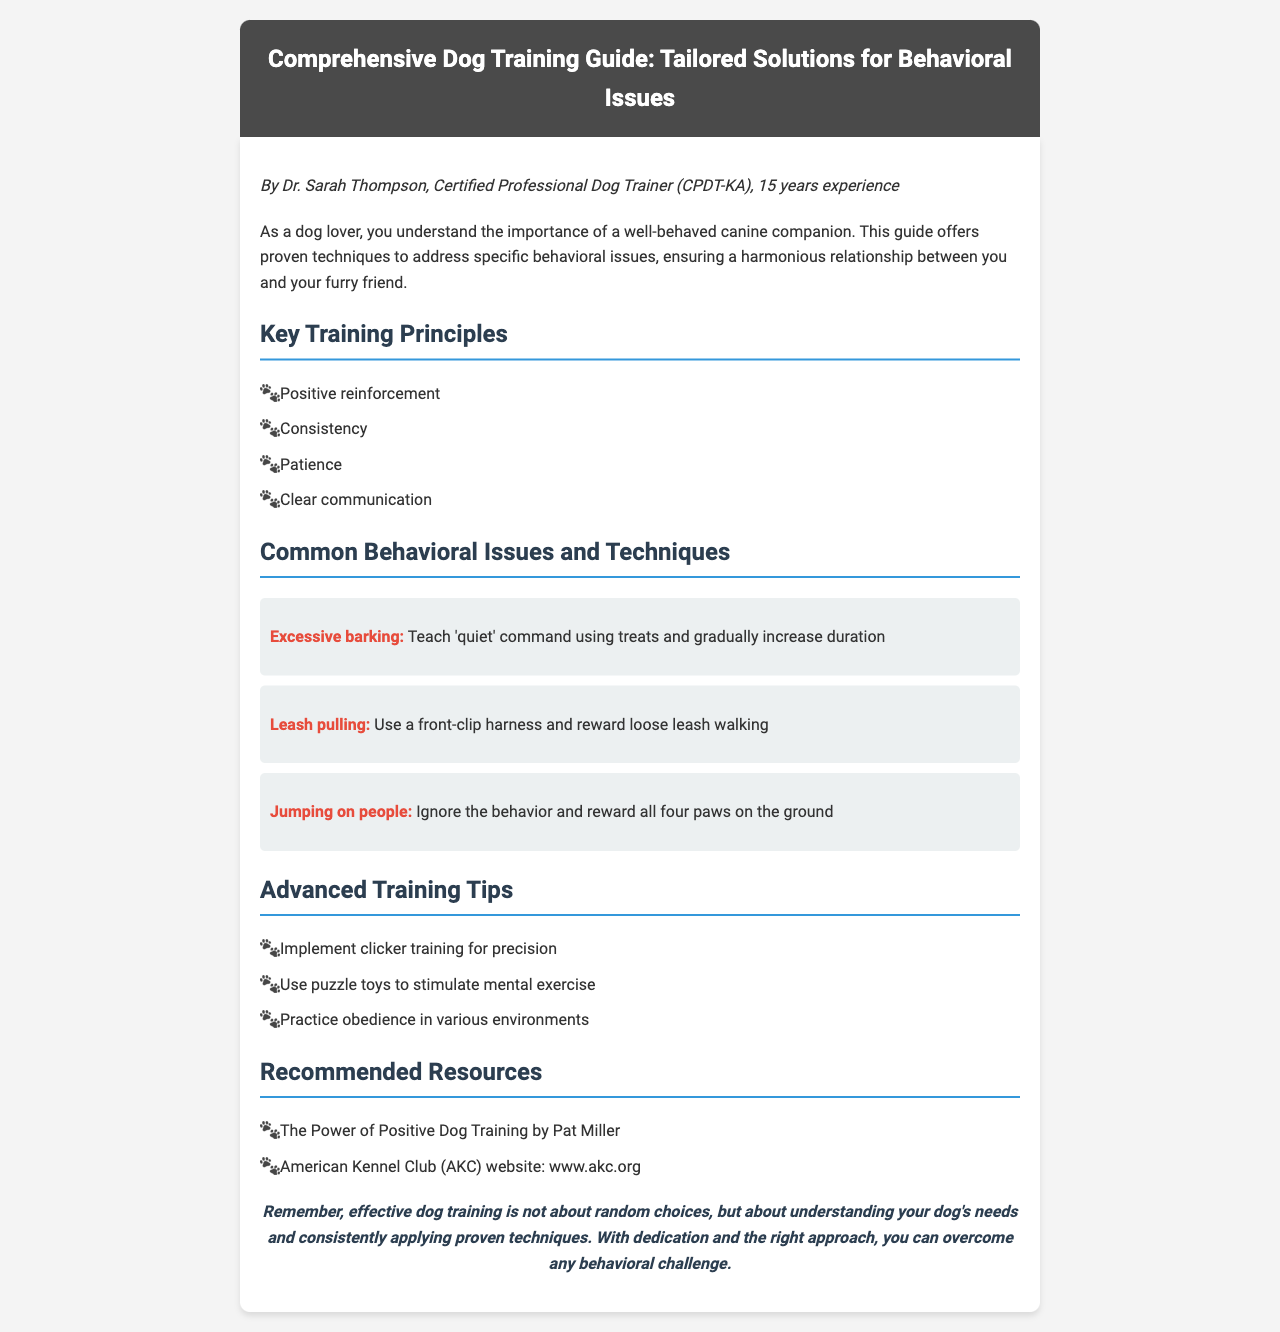What is the title of the guide? The title of the guide is clearly stated at the top of the document.
Answer: Comprehensive Dog Training Guide: Tailored Solutions for Behavioral Issues Who is the author of the guide? The author is mentioned in the trainer info section of the document.
Answer: Dr. Sarah Thompson How many years of experience does the trainer have? The document states the trainer's experience years as part of the introduction.
Answer: 15 years What behavioral issue is addressed with a 'quiet' command? The specific behavioral issue is highlighted in its section in the document.
Answer: Excessive barking Which training technique is recommended for leash pulling? This technique is specified in the common behavioral issues section.
Answer: Use a front-clip harness What advanced training method uses toys for stimulation? The method is noted in the advanced training tips segment of the document.
Answer: Puzzle toys What is the first key training principle listed? The key principles are listed at the beginning of the relevant section.
Answer: Positive reinforcement What is the publication type of this document? The document type is indicated by its structure and content focus.
Answer: Fax 